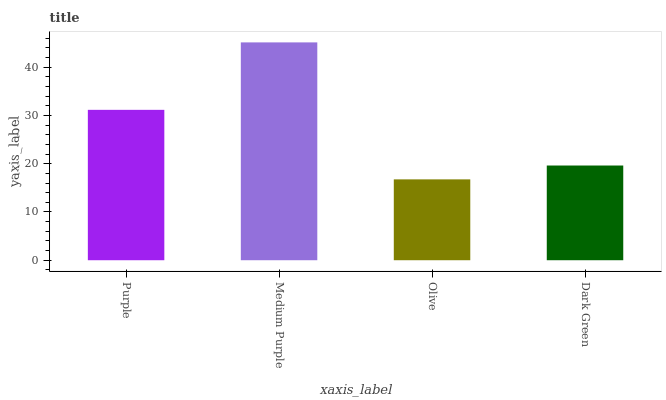Is Olive the minimum?
Answer yes or no. Yes. Is Medium Purple the maximum?
Answer yes or no. Yes. Is Medium Purple the minimum?
Answer yes or no. No. Is Olive the maximum?
Answer yes or no. No. Is Medium Purple greater than Olive?
Answer yes or no. Yes. Is Olive less than Medium Purple?
Answer yes or no. Yes. Is Olive greater than Medium Purple?
Answer yes or no. No. Is Medium Purple less than Olive?
Answer yes or no. No. Is Purple the high median?
Answer yes or no. Yes. Is Dark Green the low median?
Answer yes or no. Yes. Is Dark Green the high median?
Answer yes or no. No. Is Medium Purple the low median?
Answer yes or no. No. 